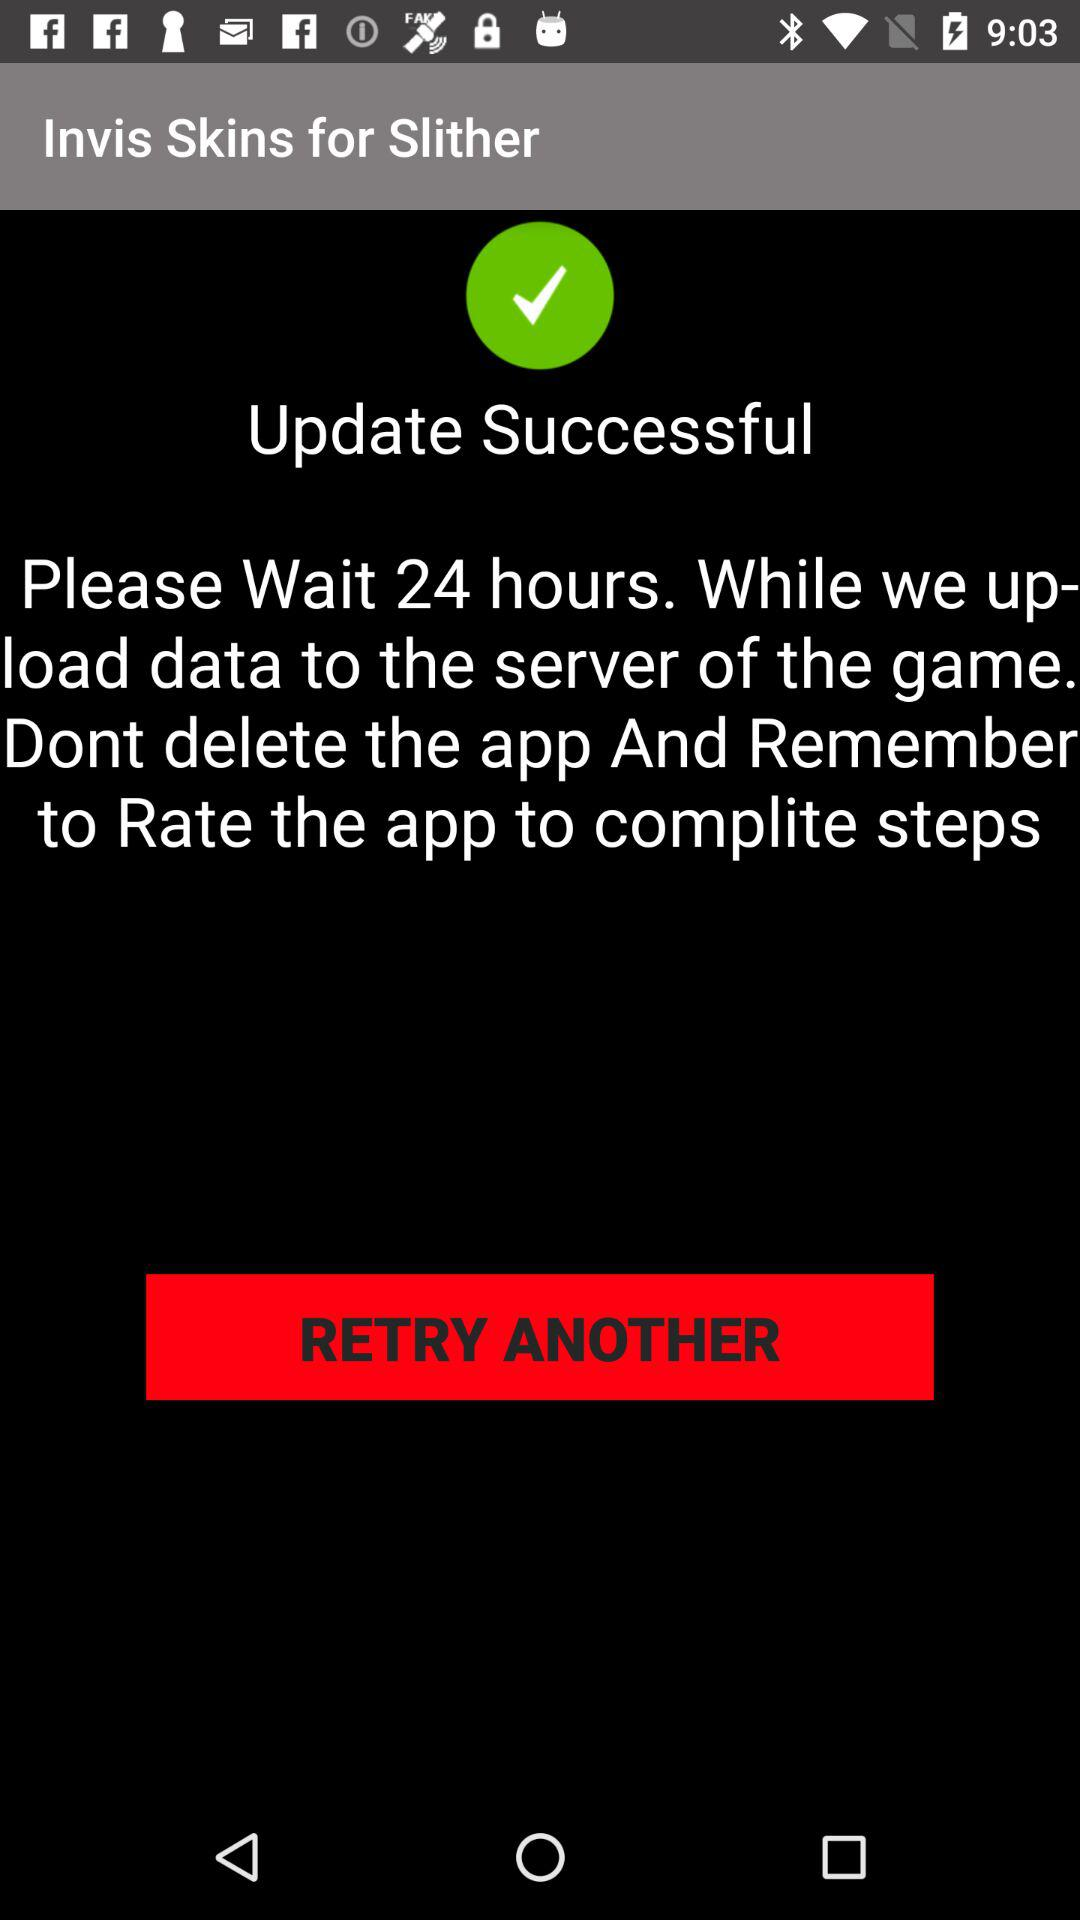How many more steps do I have to complete to play the game?
Answer the question using a single word or phrase. 1 